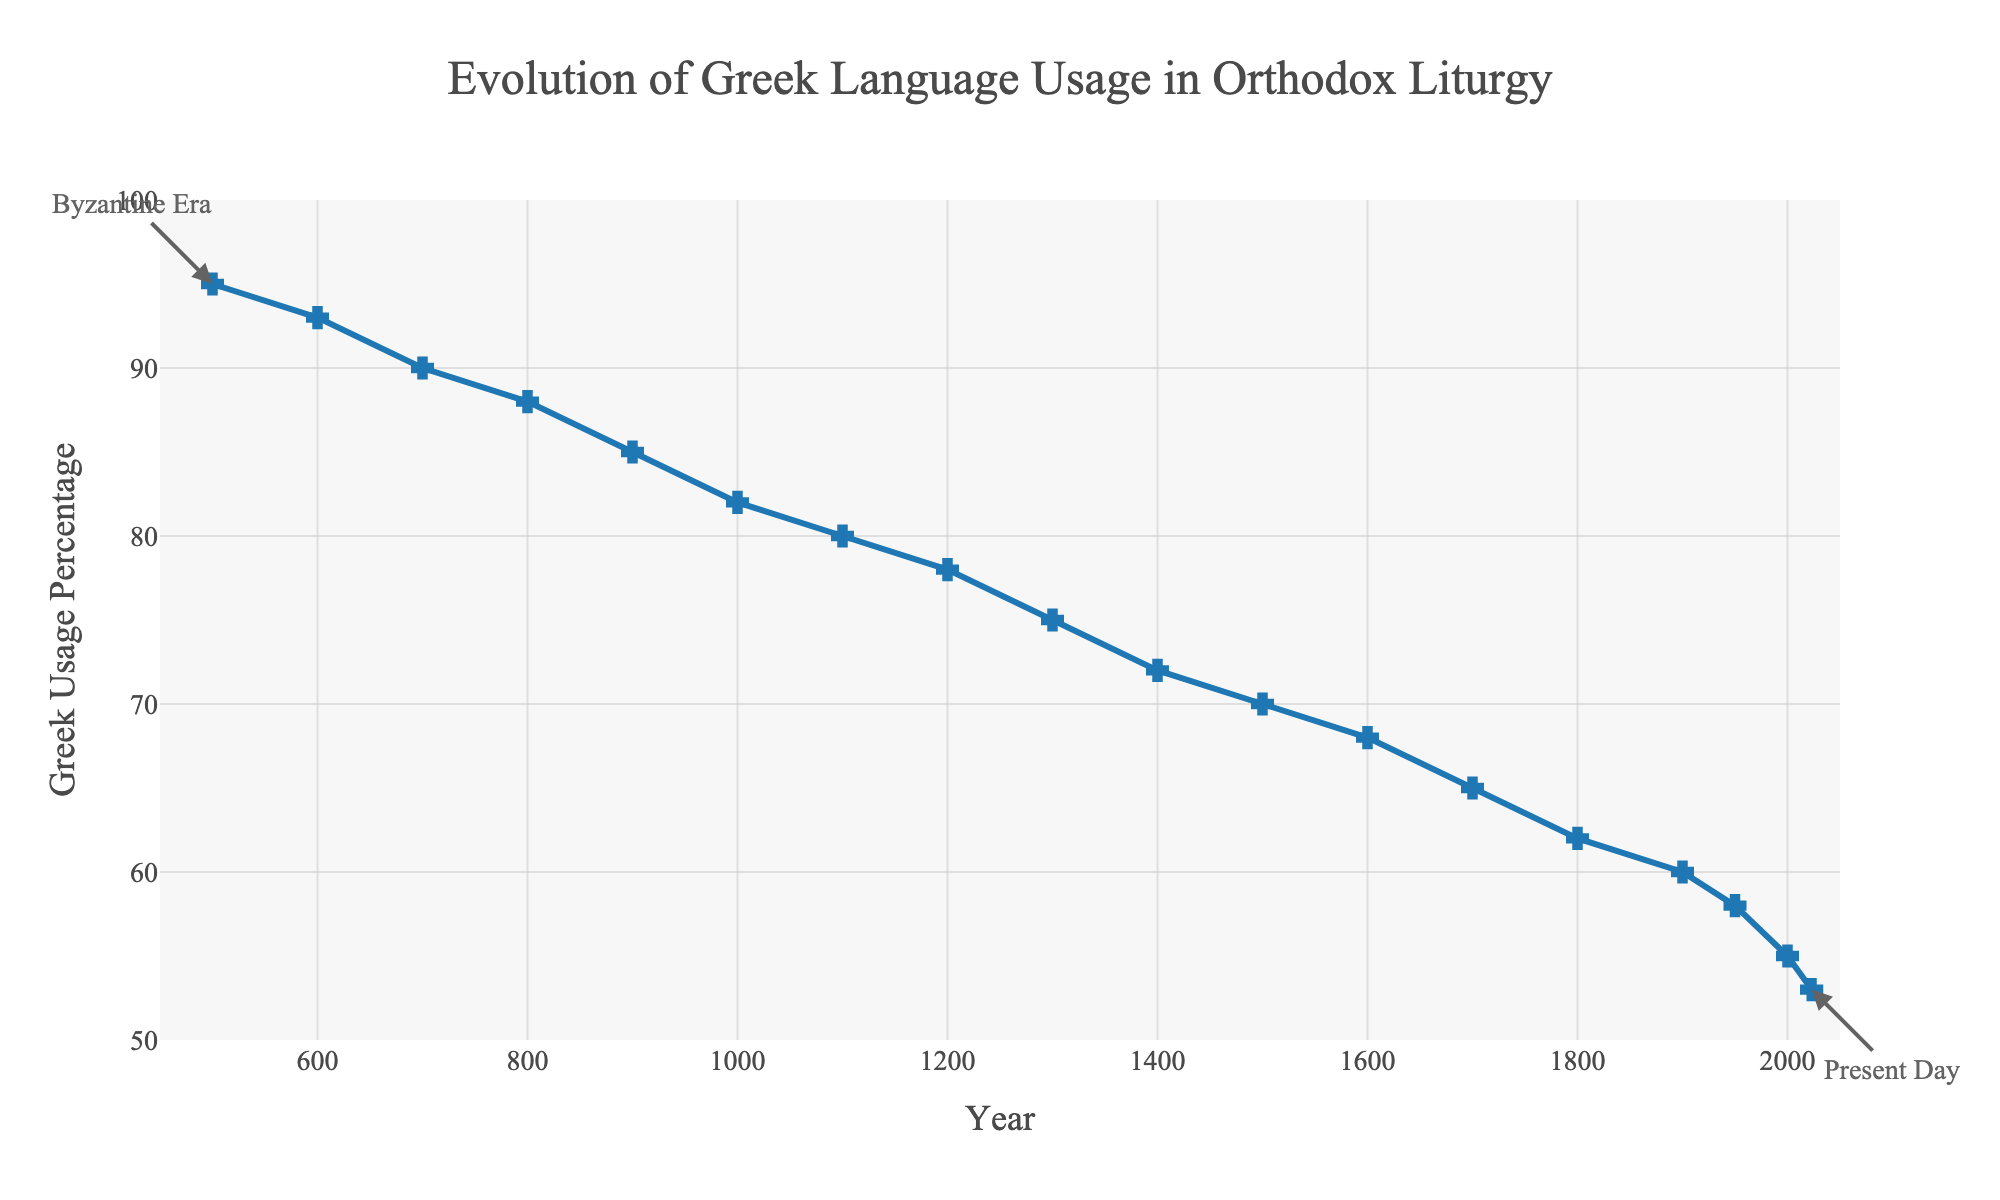What's the percentage drop in Greek language usage from the year 500 to 600? The Greek language usage in the year 500 is 95%, and in 600 it is 93%. The decrease is 95 - 93 = 2%.
Answer: 2% How does the Greek language usage in the year 1500 compare to the year 1600? In 1500, the Greek language usage is 70%, and in 1600 it is 68%. The usage decreased by 2% from 1500 to 1600.
Answer: Decreased by 2% By how much did the Greek language usage decrease between the year 1100 and 1400? The Greek language usage in the year 1100 is 80%, and in 1400 it is 72%. The decrease is 80 - 72 = 8%.
Answer: 8% What is the average percentage of Greek language usage from the 1300s to the 1500s? The years in consideration are 1300, 1400, and 1500, with percentages 75%, 72%, and 70% respectively. The average usage is (75 + 72 + 70) / 3 = 72.33%.
Answer: 72.33% What is the visual difference between the markers used for the years 500 and 2023? The markers for the years 500 and 2023 both use cross symbols, but the positions on the graph correspond to high (95%) and low (53%) usage percentage respectively. Additionally, annotations indicate "Byzantine Era" for 500 and "Present Day" for 2023.
Answer: Cross markers, different positions and annotations Which century saw the steepest decline in Greek language usage? By visually inspecting the slope of the line, the steepest decline appears between 1900 and 2000, where Greek usage dropped from 60% to 55%.
Answer: 20th century (1900s) How does the Greek language usage percentage at the start of the 1000s compare to that at the end of the 1900s? Greek language usage is 82% in 1000 and 58% in 1950. The decrease from 1000 to 1950 is 82 - 58 = 24%.
Answer: Decreased by 24% From what year to what year did Greek language usage percentage drop from 85% to 80%? Greek language usage was 85% in the year 900 and 80% in the year 1100. So, it dropped from 85% to 80% between these years.
Answer: 900 to 1100 